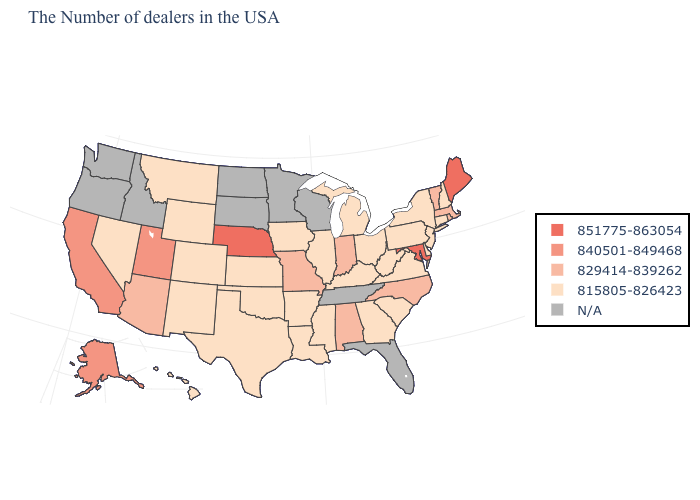Name the states that have a value in the range 815805-826423?
Give a very brief answer. New Hampshire, Connecticut, New York, New Jersey, Delaware, Pennsylvania, Virginia, South Carolina, West Virginia, Ohio, Georgia, Michigan, Kentucky, Illinois, Mississippi, Louisiana, Arkansas, Iowa, Kansas, Oklahoma, Texas, Wyoming, Colorado, New Mexico, Montana, Nevada, Hawaii. Is the legend a continuous bar?
Short answer required. No. What is the value of North Carolina?
Write a very short answer. 829414-839262. Name the states that have a value in the range N/A?
Answer briefly. Florida, Tennessee, Wisconsin, Minnesota, South Dakota, North Dakota, Idaho, Washington, Oregon. Among the states that border Mississippi , does Louisiana have the highest value?
Keep it brief. No. What is the value of Wisconsin?
Quick response, please. N/A. Does Michigan have the lowest value in the USA?
Answer briefly. Yes. Does the first symbol in the legend represent the smallest category?
Be succinct. No. What is the value of Kansas?
Short answer required. 815805-826423. What is the highest value in the USA?
Quick response, please. 851775-863054. Does the first symbol in the legend represent the smallest category?
Short answer required. No. Which states have the lowest value in the USA?
Concise answer only. New Hampshire, Connecticut, New York, New Jersey, Delaware, Pennsylvania, Virginia, South Carolina, West Virginia, Ohio, Georgia, Michigan, Kentucky, Illinois, Mississippi, Louisiana, Arkansas, Iowa, Kansas, Oklahoma, Texas, Wyoming, Colorado, New Mexico, Montana, Nevada, Hawaii. What is the lowest value in the South?
Quick response, please. 815805-826423. Which states hav the highest value in the MidWest?
Keep it brief. Nebraska. What is the value of Oregon?
Keep it brief. N/A. 